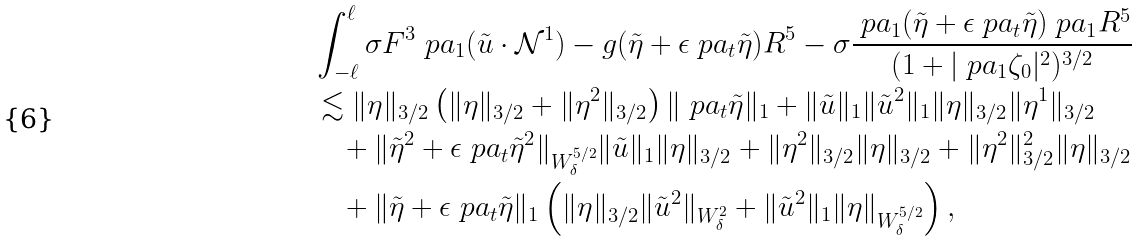<formula> <loc_0><loc_0><loc_500><loc_500>& \int _ { - \ell } ^ { \ell } \sigma F ^ { 3 } \ p a _ { 1 } ( \tilde { u } \cdot \mathcal { N } ^ { 1 } ) - g ( \tilde { \eta } + \epsilon \ p a _ { t } \tilde { \eta } ) R ^ { 5 } - \sigma \frac { \ p a _ { 1 } ( \tilde { \eta } + \epsilon \ p a _ { t } \tilde { \eta } ) \ p a _ { 1 } R ^ { 5 } } { ( 1 + | \ p a _ { 1 } \zeta _ { 0 } | ^ { 2 } ) ^ { 3 / 2 } } \\ & \lesssim \| \eta \| _ { 3 / 2 } \left ( \| \eta \| _ { 3 / 2 } + \| \eta ^ { 2 } \| _ { 3 / 2 } \right ) \| \ p a _ { t } \tilde { \eta } \| _ { 1 } + \| \tilde { u } \| _ { 1 } \| \tilde { u } ^ { 2 } \| _ { 1 } \| \eta \| _ { 3 / 2 } \| \eta ^ { 1 } \| _ { 3 / 2 } \\ & \quad + \| \tilde { \eta } ^ { 2 } + \epsilon \ p a _ { t } \tilde { \eta } ^ { 2 } \| _ { W _ { \delta } ^ { 5 / 2 } } \| \tilde { u } \| _ { 1 } \| \eta \| _ { 3 / 2 } + \| \eta ^ { 2 } \| _ { 3 / 2 } \| \eta \| _ { 3 / 2 } + \| \eta ^ { 2 } \| _ { 3 / 2 } ^ { 2 } \| \eta \| _ { 3 / 2 } \\ & \quad + \| \tilde { \eta } + \epsilon \ p a _ { t } \tilde { \eta } \| _ { 1 } \left ( \| \eta \| _ { 3 / 2 } \| \tilde { u } ^ { 2 } \| _ { W _ { \delta } ^ { 2 } } + \| \tilde { u } ^ { 2 } \| _ { 1 } \| \eta \| _ { W _ { \delta } ^ { 5 / 2 } } \right ) ,</formula> 